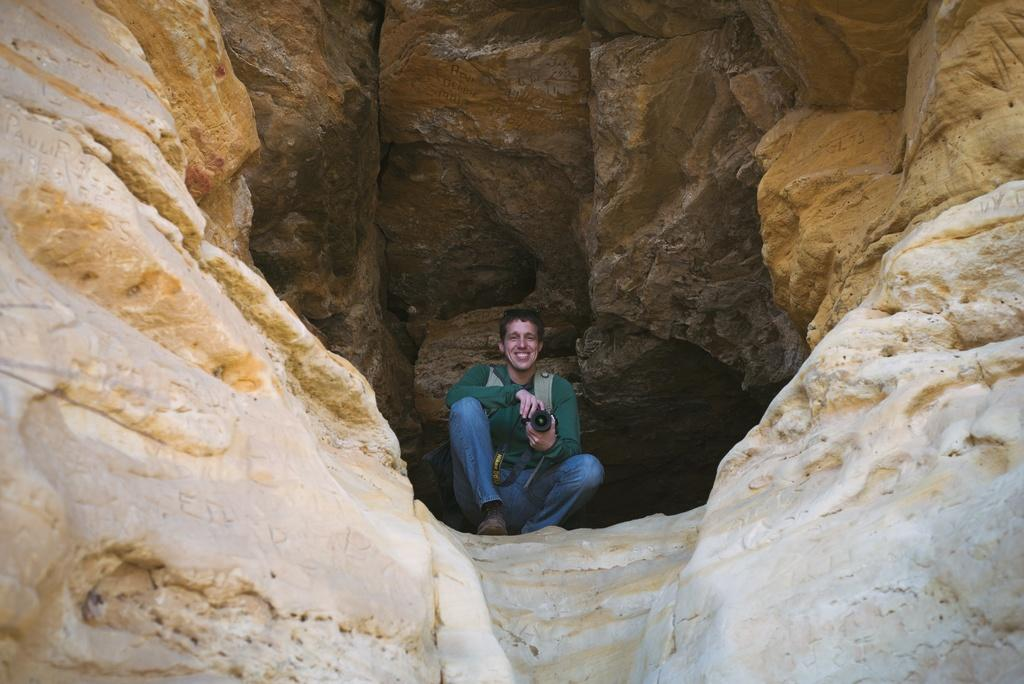What is the main subject in the foreground of the image? There is a man in the foreground of the image. What is the man doing in the image? The man is squatting in the image. What is the man holding in the image? The man is holding a camera in the image. What type of environment is depicted in the image? The scene takes place in a cave-like structure. Can you see the kitten playing with the can in the image? There is no kitten or can present in the image. Is the man's father visible in the image? The provided facts do not mention the presence of the man's father in the image. 